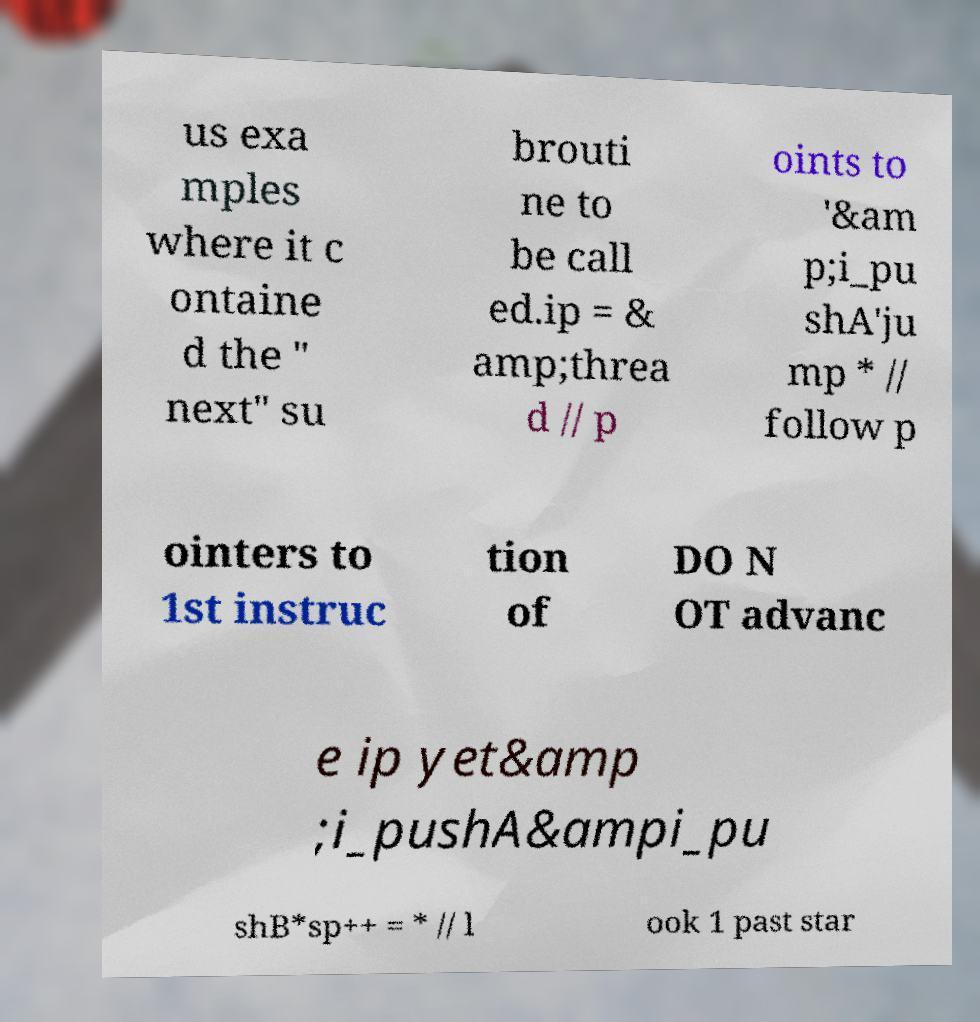What messages or text are displayed in this image? I need them in a readable, typed format. us exa mples where it c ontaine d the " next" su brouti ne to be call ed.ip = & amp;threa d // p oints to '&am p;i_pu shA'ju mp * // follow p ointers to 1st instruc tion of DO N OT advanc e ip yet&amp ;i_pushA&ampi_pu shB*sp++ = * // l ook 1 past star 